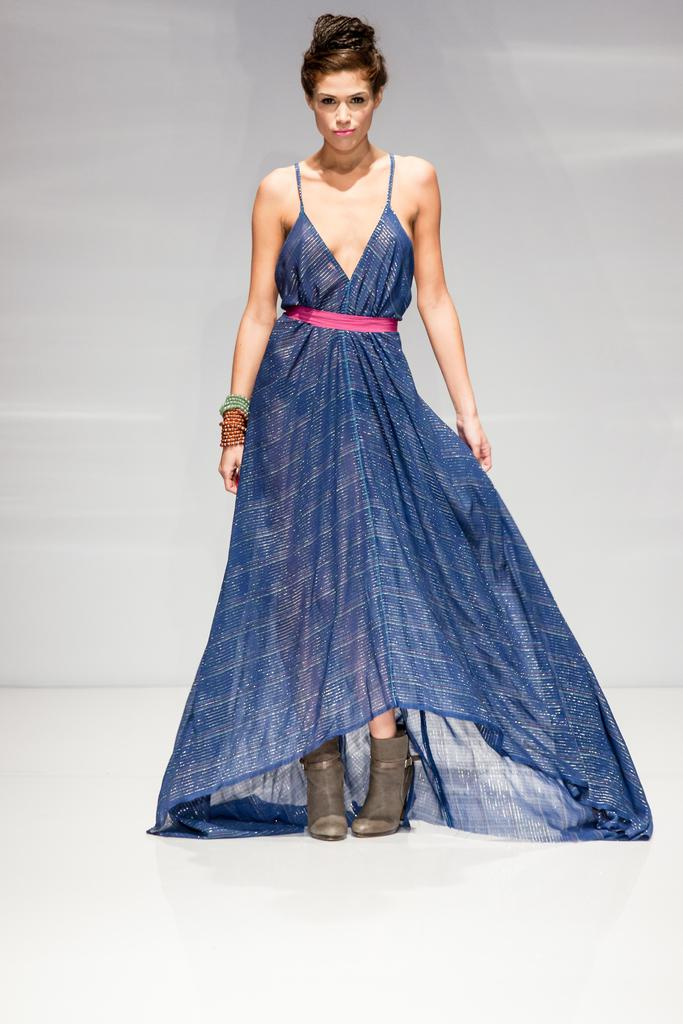Who is present in the image? There is a woman in the image. What is the woman's position in the image? The woman is standing on the floor. What type of stew is the woman cooking in the image? There is no stew present in the image; it only features a woman standing on the floor. 